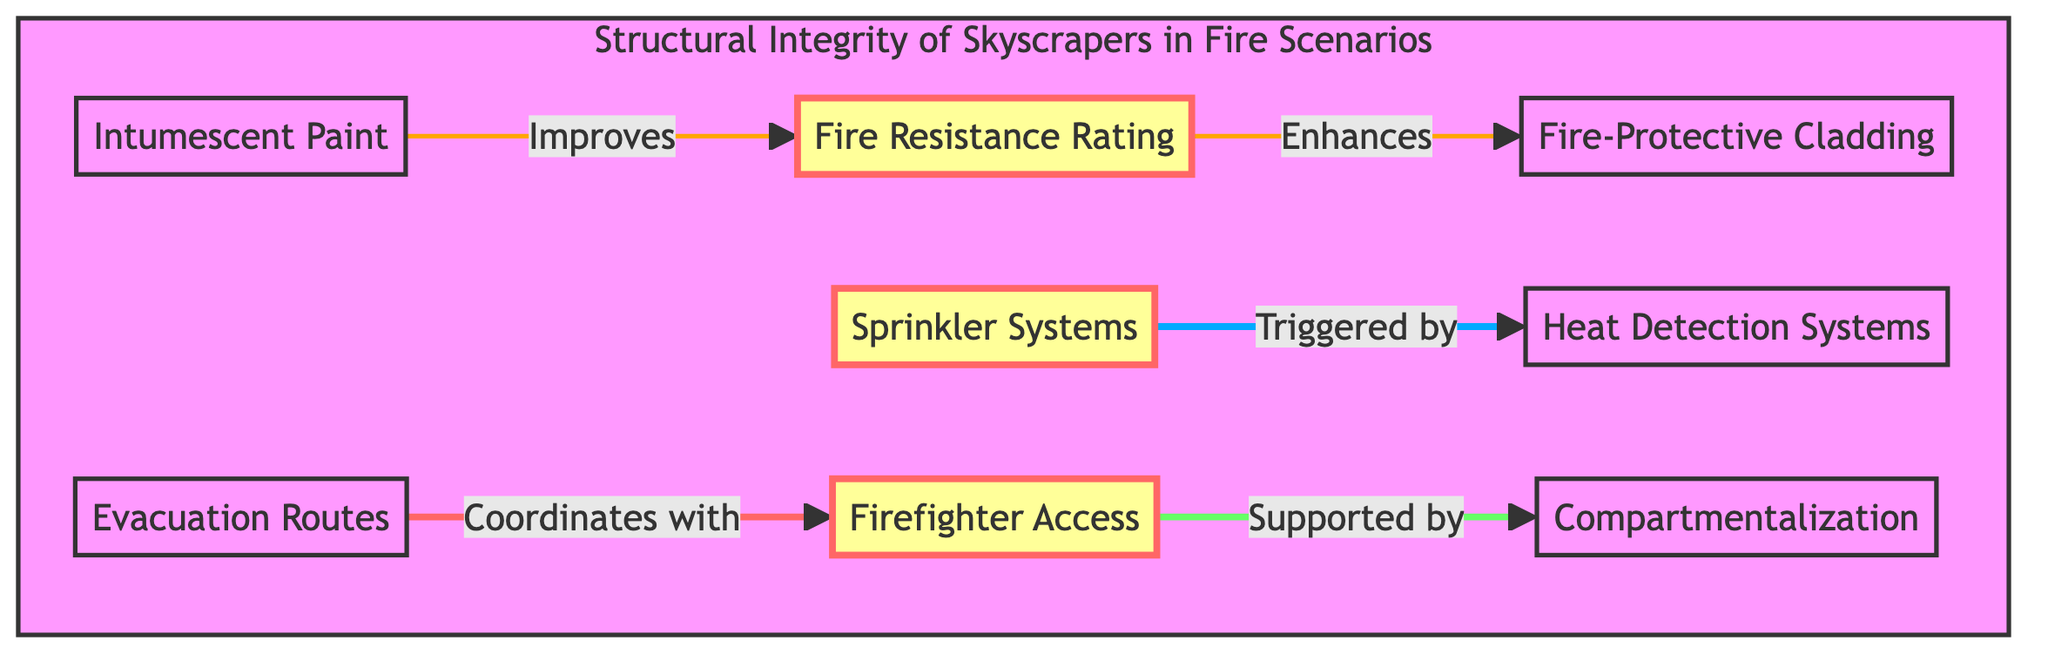What is the main component that enhances fire resistance rating? The diagram indicates that Fire-Protective Cladding enhances the Fire Resistance Rating, showing a direct relationship between the two.
Answer: Fire-Protective Cladding How many nodes are present in the diagram? By counting all the distinct elements in the flowchart labeled A through H, a total of eight nodes can be identified.
Answer: 8 Which system is triggered by heat detection systems? The diagram specifically illustrates that Sprinkler Systems are activated by Heat Detection Systems, indicating a direct flow of action.
Answer: Sprinkler Systems What is supported by firefighter access? The diagram shows that Firefighter Access is supported by Compartmentalization, as denoted by the connecting arrow from F to G.
Answer: Compartmentalization What improves fire resistance rating besides fire-protective cladding? According to the diagram, Intumescent Paint improves the Fire Resistance Rating, indicating an additional method to enhance protection.
Answer: Intumescent Paint What role do evacuation routes play in fire scenarios? The diagram states that Evacuation Routes coordinate with Firefighter Access, which illustrates their importance in ensuring safe and accessible exits during a fire.
Answer: Coordinate with Firefighter Access Which two elements are marked as important in the diagram? Observing the diagram highlights Fire Resistance Rating, Sprinkler Systems, and Firefighter Access as the important nodes, but only two are asked.
Answer: Fire Resistance Rating, Sprinkler Systems What type of relationship exists between sprinkler systems and heat detection systems? The diagram indicates a triggered relationship, where Sprinkler Systems depend on Heat Detection Systems to activate.
Answer: Triggered by Which safety feature directly interacts with both evacuation routes and firefighter access? The diagram shows that Firefighter Access is directly related to Evacuation Routes, which plays a critical role in fire scenarios, making them interconnected features.
Answer: Coordinated interaction 